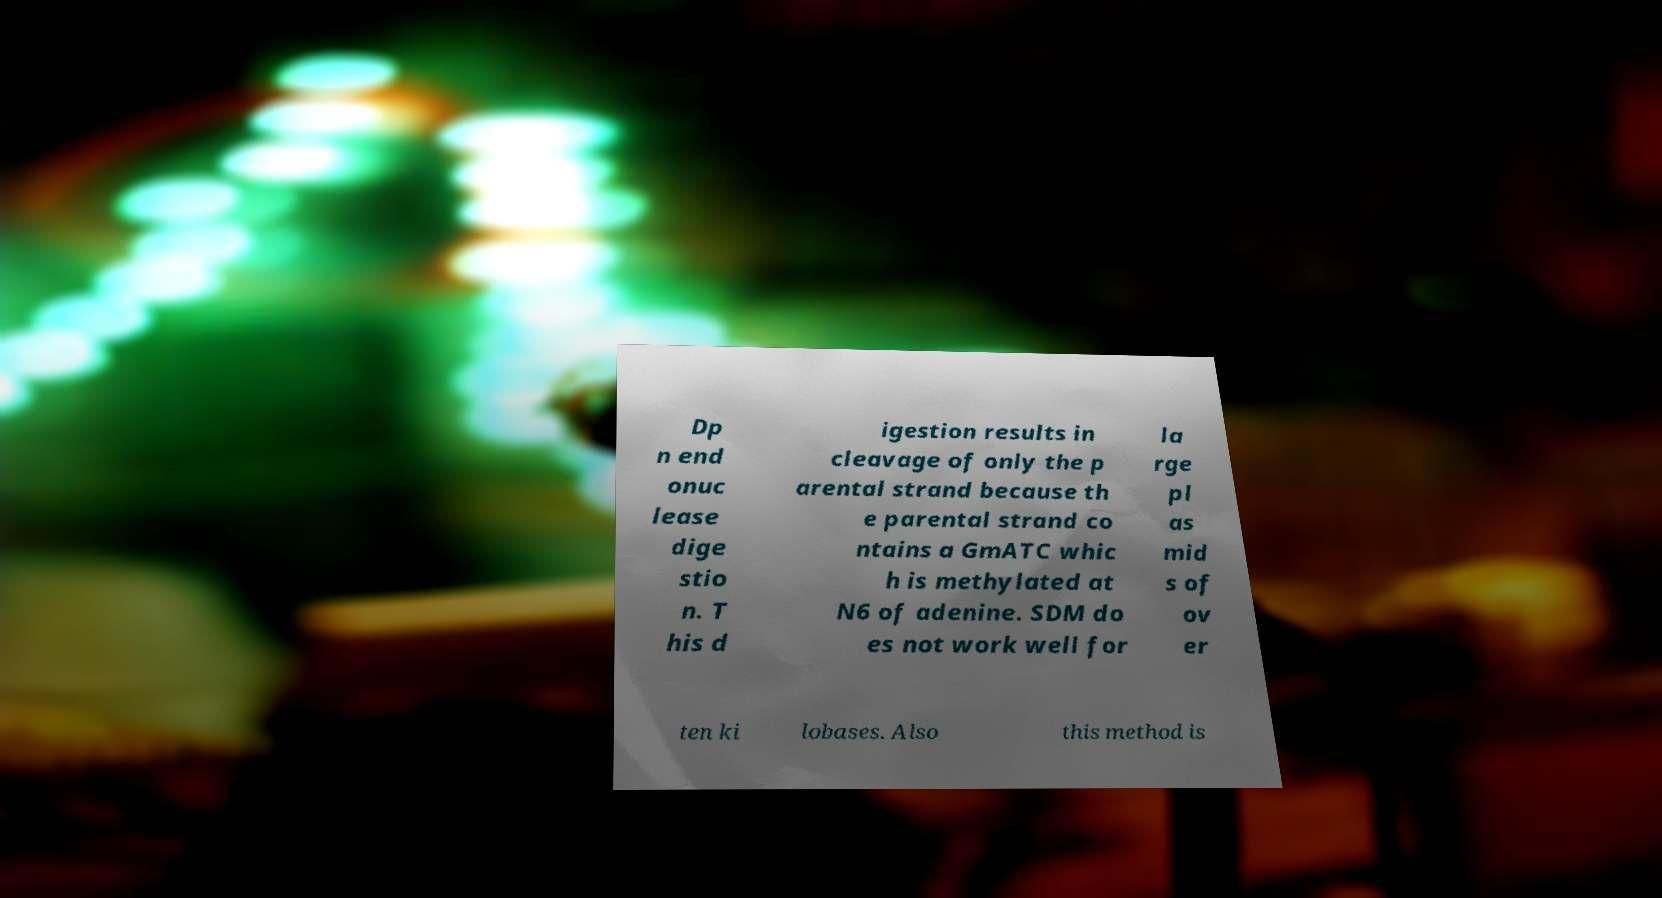For documentation purposes, I need the text within this image transcribed. Could you provide that? Dp n end onuc lease dige stio n. T his d igestion results in cleavage of only the p arental strand because th e parental strand co ntains a GmATC whic h is methylated at N6 of adenine. SDM do es not work well for la rge pl as mid s of ov er ten ki lobases. Also this method is 